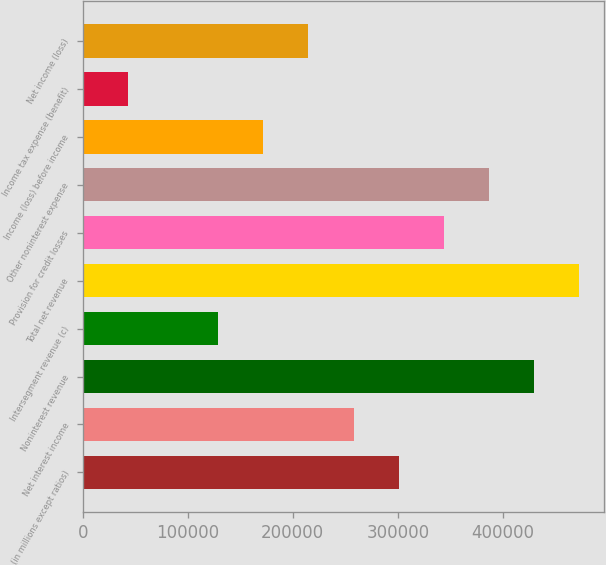Convert chart to OTSL. <chart><loc_0><loc_0><loc_500><loc_500><bar_chart><fcel>(in millions except ratios)<fcel>Net interest income<fcel>Noninterest revenue<fcel>Intersegment revenue (c)<fcel>Total net revenue<fcel>Provision for credit losses<fcel>Other noninterest expense<fcel>Income (loss) before income<fcel>Income tax expense (benefit)<fcel>Net income (loss)<nl><fcel>300907<fcel>257920<fcel>429866<fcel>128961<fcel>472852<fcel>343893<fcel>386880<fcel>171948<fcel>42988.4<fcel>214934<nl></chart> 